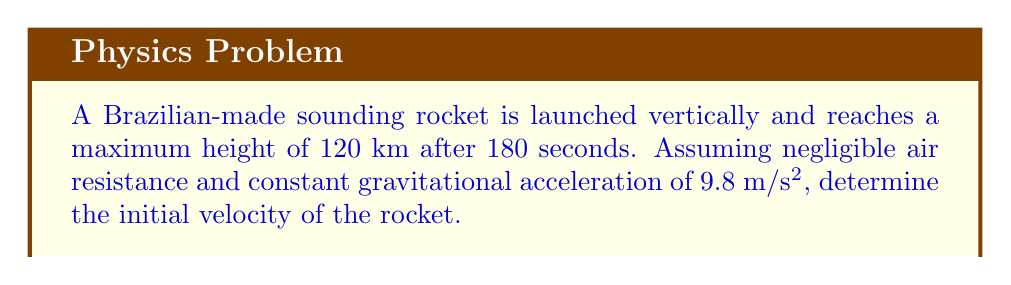Teach me how to tackle this problem. Let's approach this step-by-step using the equations of motion for constant acceleration:

1) We'll use the equation: $s = ut + \frac{1}{2}at^2$
   Where $s$ is displacement, $u$ is initial velocity, $t$ is time, and $a$ is acceleration.

2) In this case:
   $s = 120,000$ m (upwards)
   $t = 180$ s
   $a = -9.8$ m/s² (negative because gravity acts downwards)
   $u$ is what we're solving for

3) Substituting into the equation:
   $$120,000 = 180u + \frac{1}{2}(-9.8)(180)^2$$

4) Simplify the right side:
   $$120,000 = 180u - 158,760$$

5) Add 158,760 to both sides:
   $$278,760 = 180u$$

6) Divide both sides by 180:
   $$u = \frac{278,760}{180} = 1,548.67$$

Therefore, the initial velocity of the rocket was approximately 1,548.67 m/s.
Answer: 1,548.67 m/s 